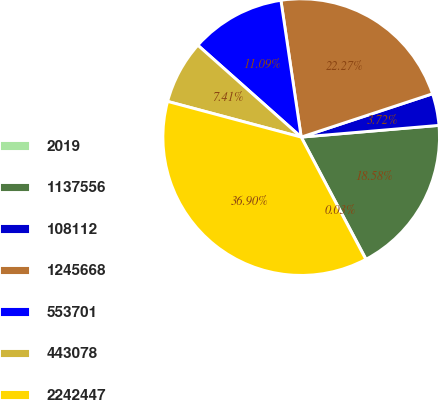Convert chart to OTSL. <chart><loc_0><loc_0><loc_500><loc_500><pie_chart><fcel>2019<fcel>1137556<fcel>108112<fcel>1245668<fcel>553701<fcel>443078<fcel>2242447<nl><fcel>0.03%<fcel>18.58%<fcel>3.72%<fcel>22.27%<fcel>11.09%<fcel>7.41%<fcel>36.9%<nl></chart> 